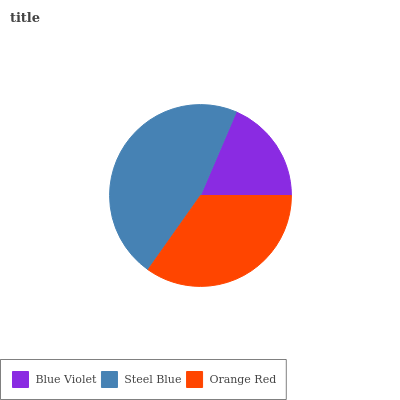Is Blue Violet the minimum?
Answer yes or no. Yes. Is Steel Blue the maximum?
Answer yes or no. Yes. Is Orange Red the minimum?
Answer yes or no. No. Is Orange Red the maximum?
Answer yes or no. No. Is Steel Blue greater than Orange Red?
Answer yes or no. Yes. Is Orange Red less than Steel Blue?
Answer yes or no. Yes. Is Orange Red greater than Steel Blue?
Answer yes or no. No. Is Steel Blue less than Orange Red?
Answer yes or no. No. Is Orange Red the high median?
Answer yes or no. Yes. Is Orange Red the low median?
Answer yes or no. Yes. Is Blue Violet the high median?
Answer yes or no. No. Is Steel Blue the low median?
Answer yes or no. No. 